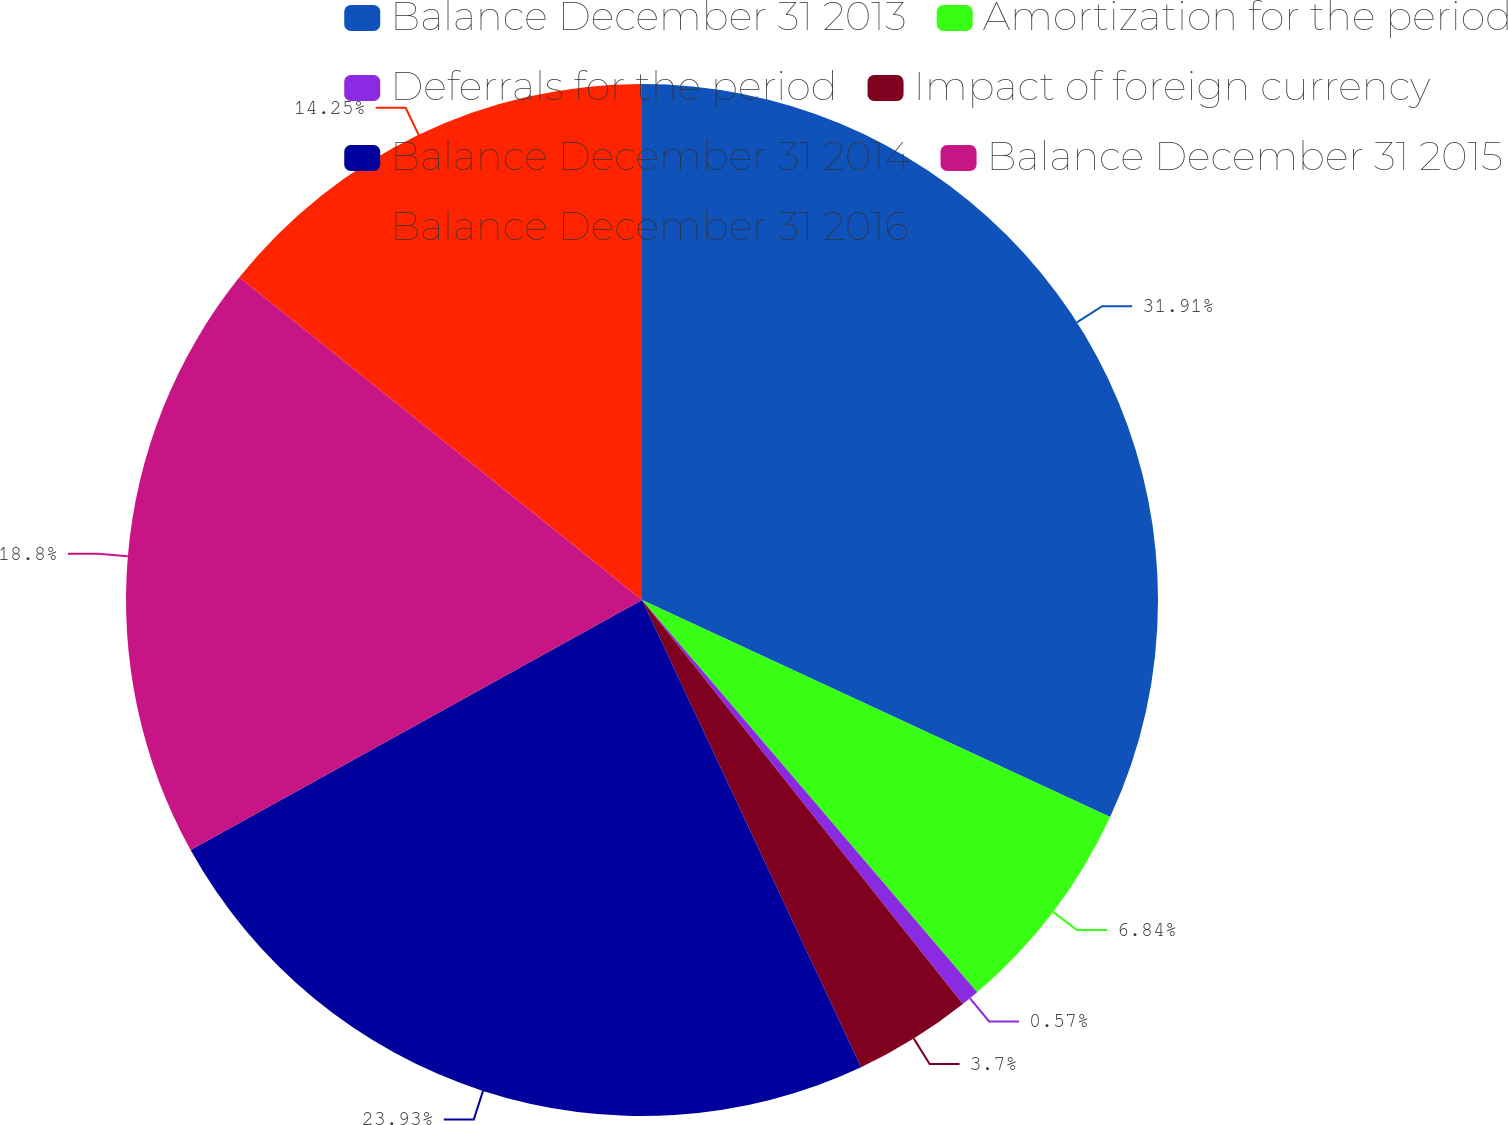<chart> <loc_0><loc_0><loc_500><loc_500><pie_chart><fcel>Balance December 31 2013<fcel>Amortization for the period<fcel>Deferrals for the period<fcel>Impact of foreign currency<fcel>Balance December 31 2014<fcel>Balance December 31 2015<fcel>Balance December 31 2016<nl><fcel>31.91%<fcel>6.84%<fcel>0.57%<fcel>3.7%<fcel>23.93%<fcel>18.8%<fcel>14.25%<nl></chart> 